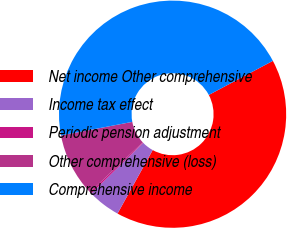Convert chart to OTSL. <chart><loc_0><loc_0><loc_500><loc_500><pie_chart><fcel>Net income Other comprehensive<fcel>Income tax effect<fcel>Periodic pension adjustment<fcel>Other comprehensive (loss)<fcel>Comprehensive income<nl><fcel>40.83%<fcel>4.65%<fcel>0.26%<fcel>9.04%<fcel>45.22%<nl></chart> 